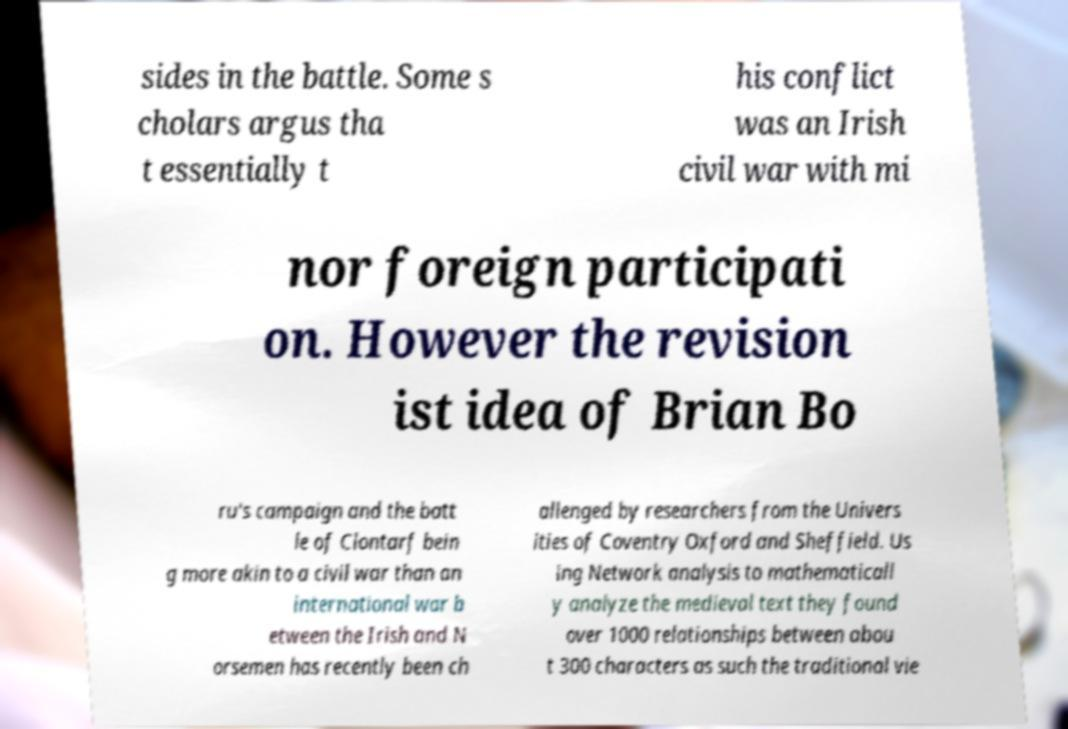I need the written content from this picture converted into text. Can you do that? sides in the battle. Some s cholars argus tha t essentially t his conflict was an Irish civil war with mi nor foreign participati on. However the revision ist idea of Brian Bo ru's campaign and the batt le of Clontarf bein g more akin to a civil war than an international war b etween the Irish and N orsemen has recently been ch allenged by researchers from the Univers ities of Coventry Oxford and Sheffield. Us ing Network analysis to mathematicall y analyze the medieval text they found over 1000 relationships between abou t 300 characters as such the traditional vie 